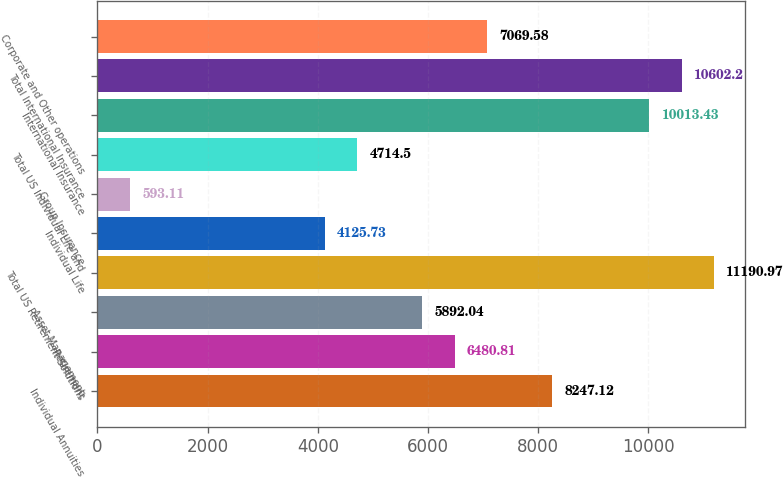Convert chart to OTSL. <chart><loc_0><loc_0><loc_500><loc_500><bar_chart><fcel>Individual Annuities<fcel>Retirement<fcel>Asset Management<fcel>Total US Retirement Solutions<fcel>Individual Life<fcel>Group Insurance<fcel>Total US Individual Life and<fcel>International Insurance<fcel>Total International Insurance<fcel>Corporate and Other operations<nl><fcel>8247.12<fcel>6480.81<fcel>5892.04<fcel>11191<fcel>4125.73<fcel>593.11<fcel>4714.5<fcel>10013.4<fcel>10602.2<fcel>7069.58<nl></chart> 